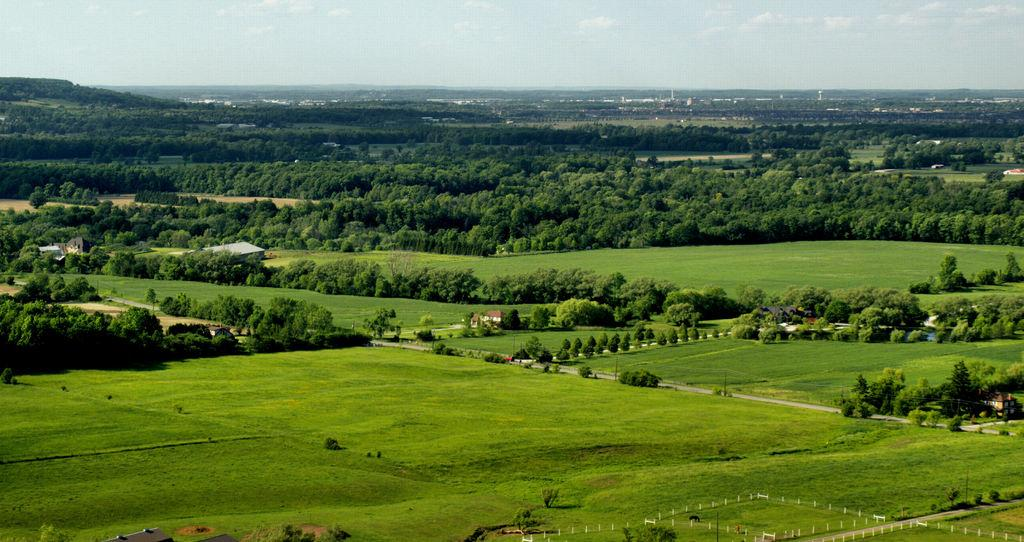What type of structures can be seen in the image? There are houses in the image. What type of vegetation is present in the image? There are trees and grass in the image. What are the poles arranged in the image? The poles are arranged in an order in the image. What type of animals can be seen on the ground in the image? There are animals on the ground in the image. What is visible at the top of the image? The sky is visible at the top of the image. What type of celery is being harvested in the image? There is no celery present in the image. What type of wool is being spun by the animals in the image? There are no animals spinning wool in the image. 